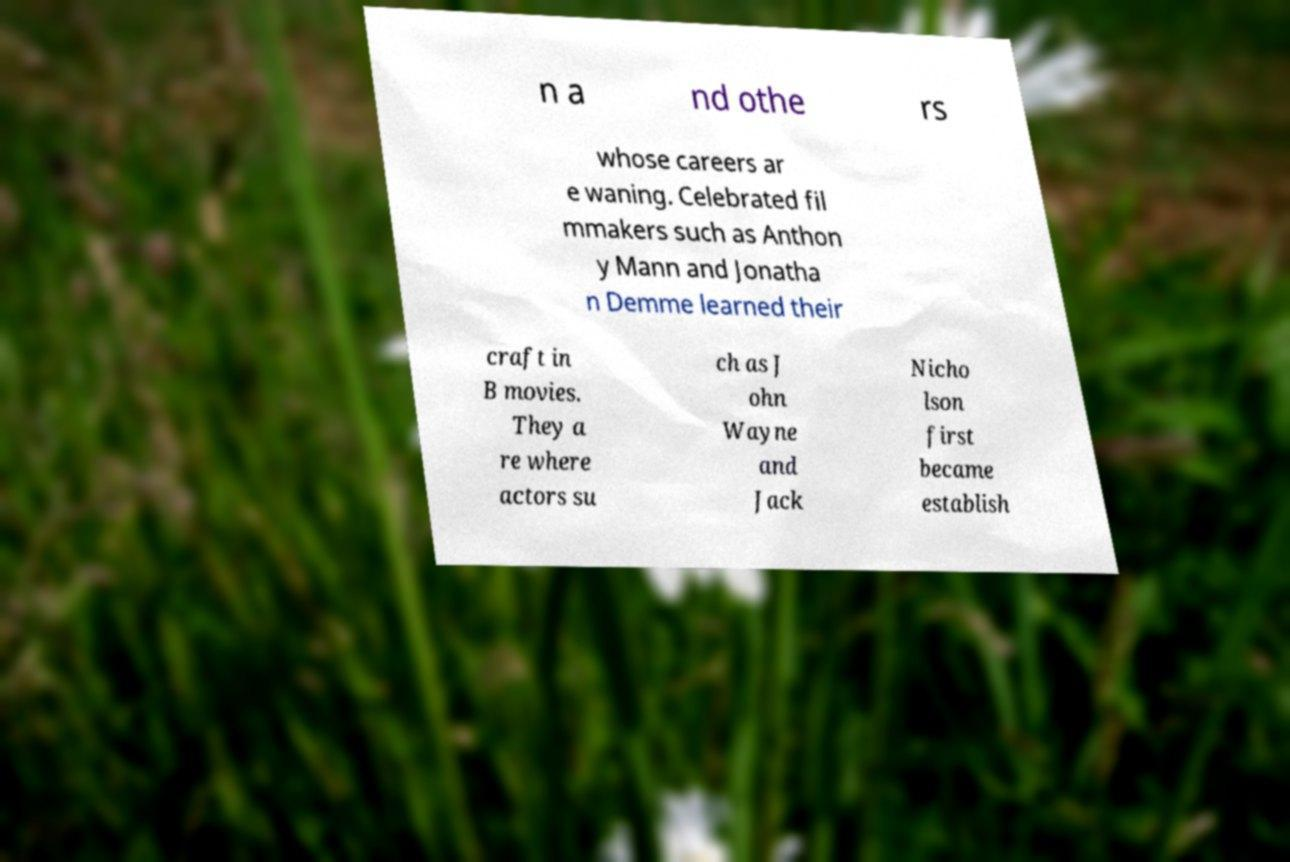I need the written content from this picture converted into text. Can you do that? n a nd othe rs whose careers ar e waning. Celebrated fil mmakers such as Anthon y Mann and Jonatha n Demme learned their craft in B movies. They a re where actors su ch as J ohn Wayne and Jack Nicho lson first became establish 